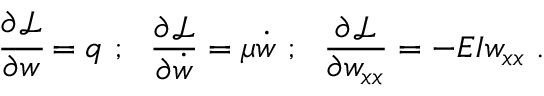Convert formula to latex. <formula><loc_0><loc_0><loc_500><loc_500>{ \cfrac { \partial { \mathcal { L } } } { \partial w } } = q ; { \frac { \partial { \mathcal { L } } } { \partial { \dot { w } } } } = \mu { \dot { w } } ; { \frac { \partial { \mathcal { L } } } { \partial w _ { x x } } } = - E I w _ { x x } .</formula> 